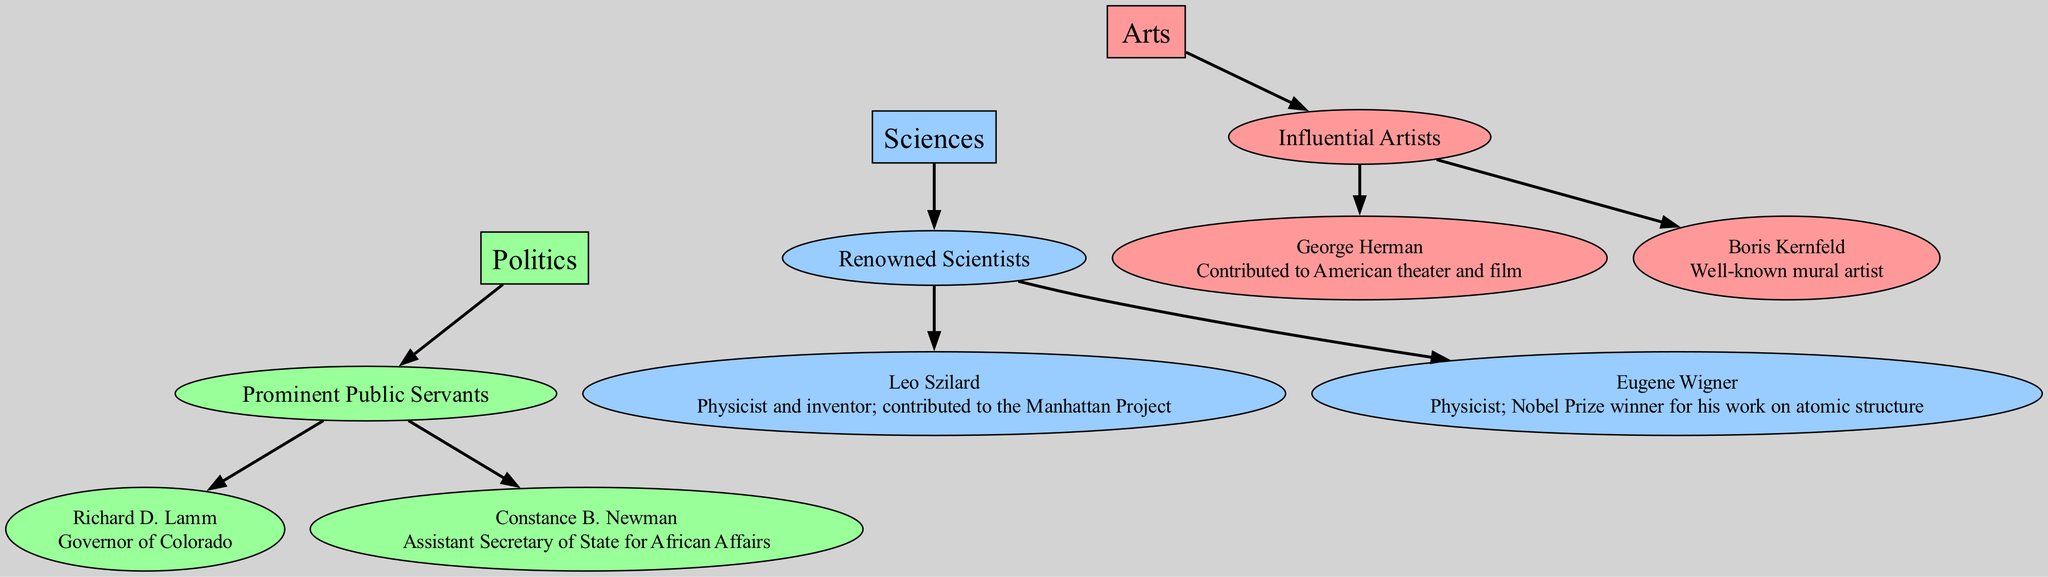What are the three main categories of contributions by Hungarian-Jewish immigrants shown in the diagram? The diagram contains three main categories under which these contributions are classified: Arts, Sciences, and Politics. These categories are clearly labeled at the top level of the diagram.
Answer: Arts, Sciences, Politics How many influential artists are listed in the diagram? The diagram includes two influential artists: George Herman and Boris Kernfeld. By reviewing the nodes connected to the "Influential Artists" node, we find these two individuals listed.
Answer: 2 Who is the renowned scientist associated with the Manhattan Project? The diagram cites Leo Szilard as the renowned scientist who contributed to the Manhattan Project. This can be determined by looking at the "Renowned Scientists" node, which connects to Szilard and includes a note about his contributions.
Answer: Leo Szilard Which politician served as Governor of Colorado? The diagram lists Richard D. Lamm as the politician who served as Governor of Colorado. This can be identified by locating the "Prominent Public Servants" category and finding the connection leading to Lamm.
Answer: Richard D. Lamm What is the color representing the Sciences category in the diagram? The color representing the Sciences category in the diagram is blue, specifically indicated in the color scheme section. By checking the colors assigned to each major category, we find that sciences are shown using a specific blue shade.
Answer: #99CCFF Which two influential figures are connected under the Politics category? The diagram indicates that Richard D. Lamm and Constance B. Newman are the two influential figures connected under the Politics category. This can be deduced by analyzing the connections originating from the "Prominent Public Servants" node.
Answer: Richard D. Lamm and Constance B. Newman How many edges connect the Arts category to its respective influential artists? There are two edges connecting the Arts category to its respective influential artists, George Herman and Boris Kernfeld. This can be determined by counting the connections emanating from the "Influential Artists" node.
Answer: 2 What significant achievement is Eugene Wigner known for according to the diagram? The diagram notes that Eugene Wigner is a Nobel Prize winner for his work on atomic structure. This information is clearly stated in the details associated with the "Eugene Wigner" node connected to "Renowned Scientists".
Answer: Nobel Prize winner for his work on atomic structure How many nodes represent public servants in the diagram? The diagram features two nodes representing public servants: Richard D. Lamm and Constance B. Newman. By reviewing the "Prominent Public Servants" node, we can identify these two figures as part of that group.
Answer: 2 What contributions to Amerian theater and film are attributed to George Herman? The diagram attributes contributions to American theater and film to George Herman. This information can be found in the details of the "George Herman" node, which specifies his impact in these areas.
Answer: Contributed to American theater and film 